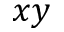Convert formula to latex. <formula><loc_0><loc_0><loc_500><loc_500>x y</formula> 